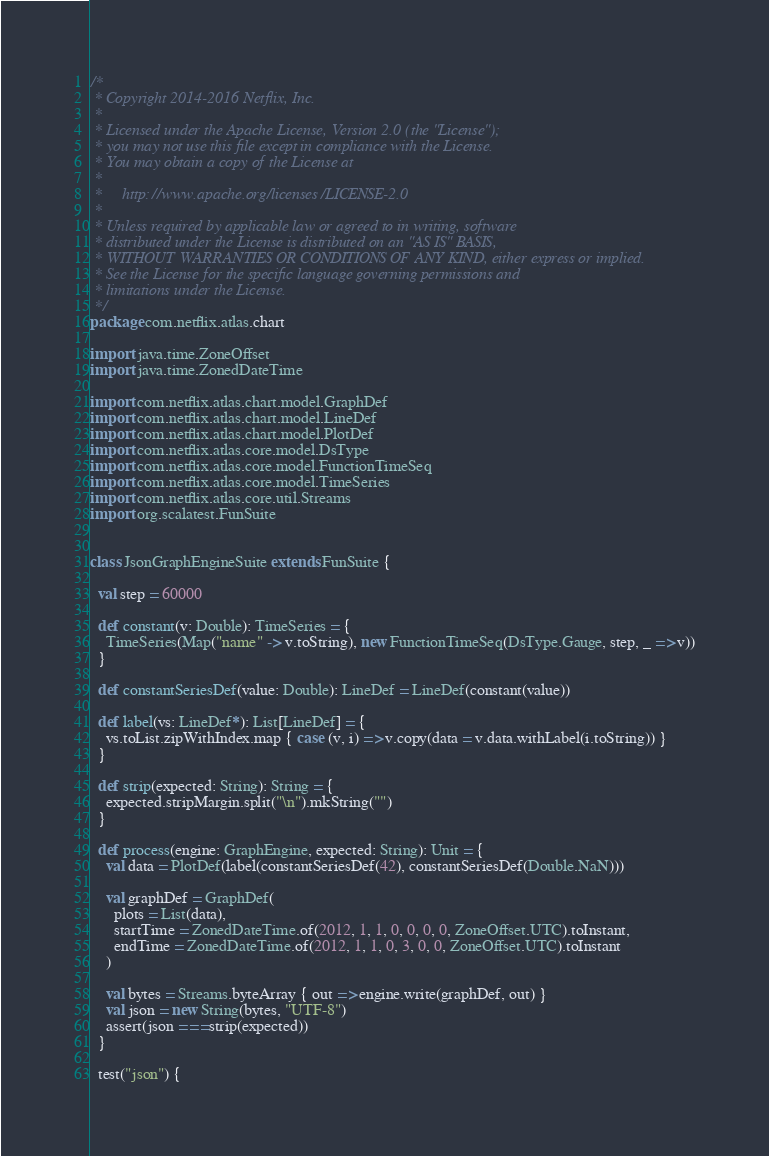Convert code to text. <code><loc_0><loc_0><loc_500><loc_500><_Scala_>/*
 * Copyright 2014-2016 Netflix, Inc.
 *
 * Licensed under the Apache License, Version 2.0 (the "License");
 * you may not use this file except in compliance with the License.
 * You may obtain a copy of the License at
 *
 *     http://www.apache.org/licenses/LICENSE-2.0
 *
 * Unless required by applicable law or agreed to in writing, software
 * distributed under the License is distributed on an "AS IS" BASIS,
 * WITHOUT WARRANTIES OR CONDITIONS OF ANY KIND, either express or implied.
 * See the License for the specific language governing permissions and
 * limitations under the License.
 */
package com.netflix.atlas.chart

import java.time.ZoneOffset
import java.time.ZonedDateTime

import com.netflix.atlas.chart.model.GraphDef
import com.netflix.atlas.chart.model.LineDef
import com.netflix.atlas.chart.model.PlotDef
import com.netflix.atlas.core.model.DsType
import com.netflix.atlas.core.model.FunctionTimeSeq
import com.netflix.atlas.core.model.TimeSeries
import com.netflix.atlas.core.util.Streams
import org.scalatest.FunSuite


class JsonGraphEngineSuite extends FunSuite {

  val step = 60000

  def constant(v: Double): TimeSeries = {
    TimeSeries(Map("name" -> v.toString), new FunctionTimeSeq(DsType.Gauge, step, _ => v))
  }

  def constantSeriesDef(value: Double): LineDef = LineDef(constant(value))

  def label(vs: LineDef*): List[LineDef] = {
    vs.toList.zipWithIndex.map { case (v, i) => v.copy(data = v.data.withLabel(i.toString)) }
  }

  def strip(expected: String): String = {
    expected.stripMargin.split("\n").mkString("")
  }

  def process(engine: GraphEngine, expected: String): Unit = {
    val data = PlotDef(label(constantSeriesDef(42), constantSeriesDef(Double.NaN)))

    val graphDef = GraphDef(
      plots = List(data),
      startTime = ZonedDateTime.of(2012, 1, 1, 0, 0, 0, 0, ZoneOffset.UTC).toInstant,
      endTime = ZonedDateTime.of(2012, 1, 1, 0, 3, 0, 0, ZoneOffset.UTC).toInstant
    )

    val bytes = Streams.byteArray { out => engine.write(graphDef, out) }
    val json = new String(bytes, "UTF-8")
    assert(json === strip(expected))
  }

  test("json") {</code> 